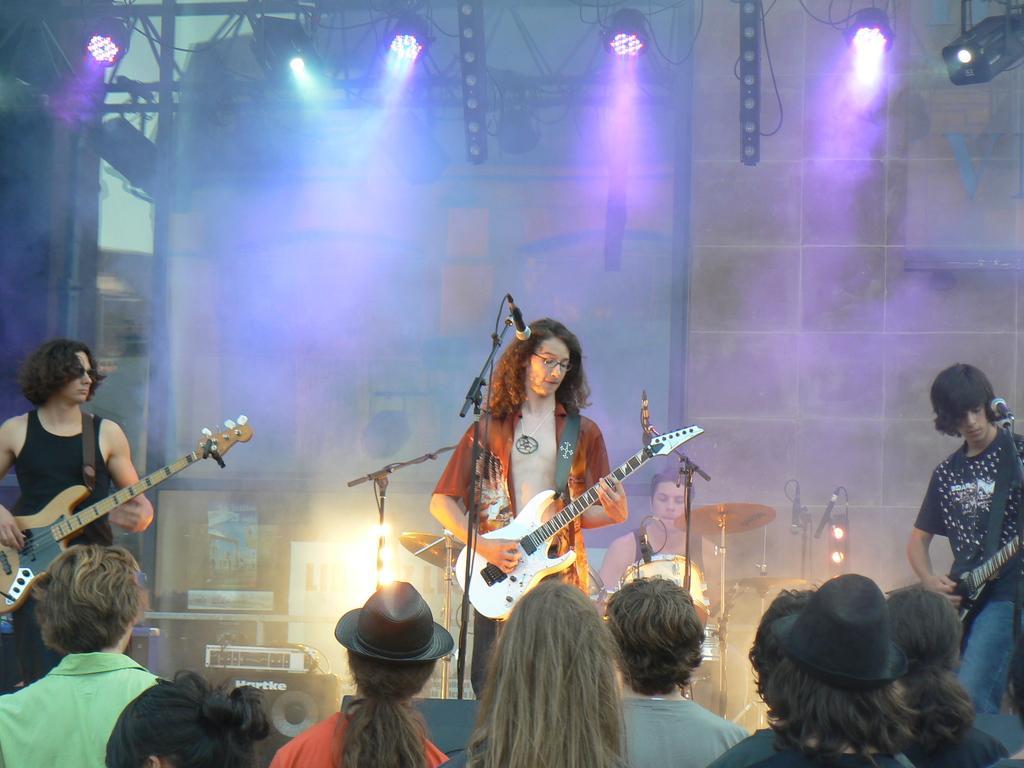Can you describe this image briefly? In this image I see 3 men and all of them are holding guitars and there are few people over here. In the background I see the lights, a man and he is near the drums. 